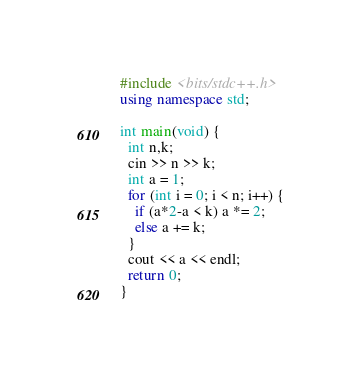<code> <loc_0><loc_0><loc_500><loc_500><_C++_>#include <bits/stdc++.h>
using namespace std;

int main(void) {
  int n,k;
  cin >> n >> k;
  int a = 1;
  for (int i = 0; i < n; i++) {
    if (a*2-a < k) a *= 2;
    else a += k;
  }
  cout << a << endl;
  return 0;
}</code> 